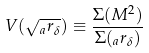<formula> <loc_0><loc_0><loc_500><loc_500>V ( \sqrt { _ { a } r _ { \delta } } ) \equiv \frac { \Sigma ( M ^ { 2 } ) } { \Sigma ( _ { a } r _ { \delta } ) }</formula> 